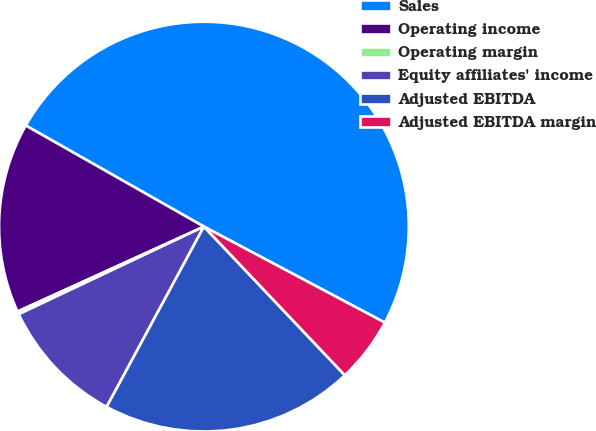Convert chart to OTSL. <chart><loc_0><loc_0><loc_500><loc_500><pie_chart><fcel>Sales<fcel>Operating income<fcel>Operating margin<fcel>Equity affiliates' income<fcel>Adjusted EBITDA<fcel>Adjusted EBITDA margin<nl><fcel>49.55%<fcel>15.02%<fcel>0.23%<fcel>10.09%<fcel>19.95%<fcel>5.16%<nl></chart> 